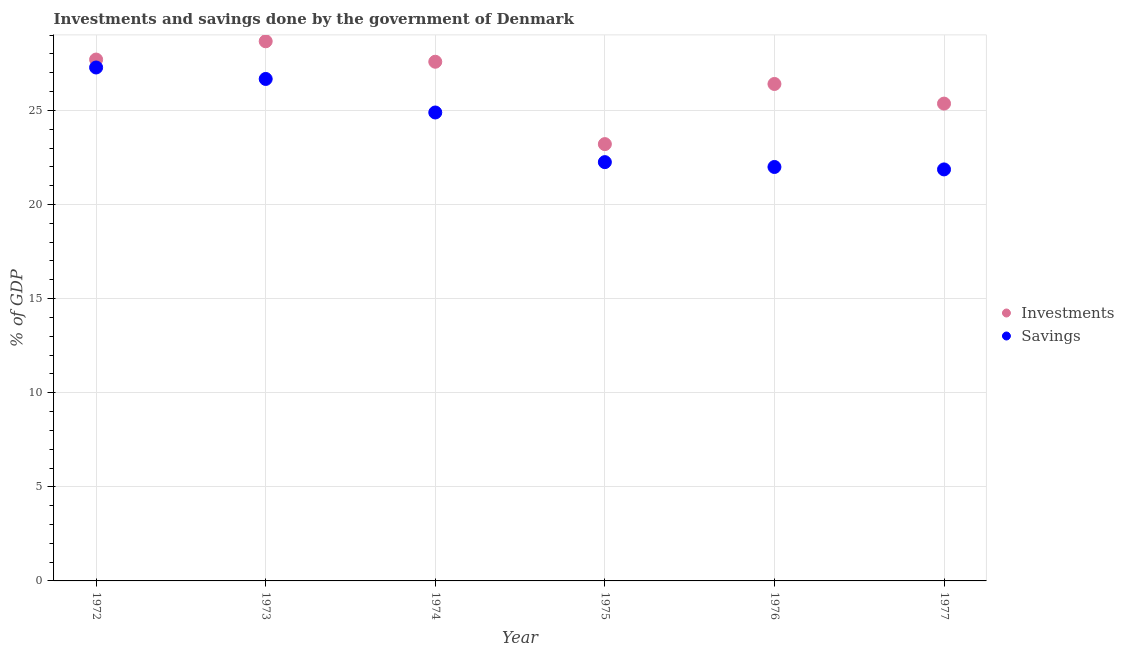How many different coloured dotlines are there?
Offer a terse response. 2. What is the investments of government in 1972?
Your answer should be very brief. 27.7. Across all years, what is the maximum investments of government?
Your answer should be very brief. 28.67. Across all years, what is the minimum savings of government?
Your answer should be compact. 21.87. In which year was the savings of government maximum?
Your response must be concise. 1972. In which year was the savings of government minimum?
Keep it short and to the point. 1977. What is the total savings of government in the graph?
Keep it short and to the point. 144.96. What is the difference between the savings of government in 1973 and that in 1976?
Make the answer very short. 4.68. What is the difference between the savings of government in 1975 and the investments of government in 1974?
Offer a very short reply. -5.33. What is the average savings of government per year?
Your answer should be compact. 24.16. In the year 1973, what is the difference between the investments of government and savings of government?
Ensure brevity in your answer.  2. In how many years, is the savings of government greater than 20 %?
Offer a terse response. 6. What is the ratio of the savings of government in 1972 to that in 1976?
Ensure brevity in your answer.  1.24. What is the difference between the highest and the second highest savings of government?
Offer a terse response. 0.61. What is the difference between the highest and the lowest savings of government?
Make the answer very short. 5.42. In how many years, is the investments of government greater than the average investments of government taken over all years?
Your answer should be compact. 3. Is the sum of the savings of government in 1974 and 1976 greater than the maximum investments of government across all years?
Provide a succinct answer. Yes. Is the investments of government strictly greater than the savings of government over the years?
Your answer should be very brief. Yes. Is the savings of government strictly less than the investments of government over the years?
Make the answer very short. Yes. How many dotlines are there?
Provide a short and direct response. 2. How many legend labels are there?
Provide a short and direct response. 2. What is the title of the graph?
Provide a short and direct response. Investments and savings done by the government of Denmark. What is the label or title of the X-axis?
Make the answer very short. Year. What is the label or title of the Y-axis?
Provide a succinct answer. % of GDP. What is the % of GDP in Investments in 1972?
Keep it short and to the point. 27.7. What is the % of GDP of Savings in 1972?
Your answer should be compact. 27.28. What is the % of GDP in Investments in 1973?
Your response must be concise. 28.67. What is the % of GDP in Savings in 1973?
Your answer should be compact. 26.67. What is the % of GDP of Investments in 1974?
Give a very brief answer. 27.59. What is the % of GDP in Savings in 1974?
Ensure brevity in your answer.  24.89. What is the % of GDP of Investments in 1975?
Offer a terse response. 23.21. What is the % of GDP in Savings in 1975?
Give a very brief answer. 22.25. What is the % of GDP in Investments in 1976?
Provide a succinct answer. 26.41. What is the % of GDP of Savings in 1976?
Give a very brief answer. 21.99. What is the % of GDP in Investments in 1977?
Offer a very short reply. 25.36. What is the % of GDP of Savings in 1977?
Provide a short and direct response. 21.87. Across all years, what is the maximum % of GDP in Investments?
Provide a short and direct response. 28.67. Across all years, what is the maximum % of GDP of Savings?
Your answer should be compact. 27.28. Across all years, what is the minimum % of GDP in Investments?
Give a very brief answer. 23.21. Across all years, what is the minimum % of GDP of Savings?
Keep it short and to the point. 21.87. What is the total % of GDP of Investments in the graph?
Ensure brevity in your answer.  158.94. What is the total % of GDP of Savings in the graph?
Offer a very short reply. 144.96. What is the difference between the % of GDP in Investments in 1972 and that in 1973?
Ensure brevity in your answer.  -0.97. What is the difference between the % of GDP in Savings in 1972 and that in 1973?
Your answer should be very brief. 0.61. What is the difference between the % of GDP in Investments in 1972 and that in 1974?
Your response must be concise. 0.12. What is the difference between the % of GDP of Savings in 1972 and that in 1974?
Make the answer very short. 2.39. What is the difference between the % of GDP in Investments in 1972 and that in 1975?
Your answer should be compact. 4.49. What is the difference between the % of GDP in Savings in 1972 and that in 1975?
Give a very brief answer. 5.03. What is the difference between the % of GDP in Investments in 1972 and that in 1976?
Give a very brief answer. 1.3. What is the difference between the % of GDP of Savings in 1972 and that in 1976?
Your response must be concise. 5.29. What is the difference between the % of GDP of Investments in 1972 and that in 1977?
Ensure brevity in your answer.  2.34. What is the difference between the % of GDP of Savings in 1972 and that in 1977?
Your response must be concise. 5.42. What is the difference between the % of GDP of Investments in 1973 and that in 1974?
Ensure brevity in your answer.  1.09. What is the difference between the % of GDP of Savings in 1973 and that in 1974?
Offer a very short reply. 1.78. What is the difference between the % of GDP in Investments in 1973 and that in 1975?
Your response must be concise. 5.46. What is the difference between the % of GDP in Savings in 1973 and that in 1975?
Offer a terse response. 4.42. What is the difference between the % of GDP in Investments in 1973 and that in 1976?
Provide a succinct answer. 2.27. What is the difference between the % of GDP in Savings in 1973 and that in 1976?
Offer a terse response. 4.68. What is the difference between the % of GDP of Investments in 1973 and that in 1977?
Ensure brevity in your answer.  3.31. What is the difference between the % of GDP in Savings in 1973 and that in 1977?
Keep it short and to the point. 4.81. What is the difference between the % of GDP in Investments in 1974 and that in 1975?
Your answer should be compact. 4.38. What is the difference between the % of GDP in Savings in 1974 and that in 1975?
Make the answer very short. 2.64. What is the difference between the % of GDP of Investments in 1974 and that in 1976?
Provide a succinct answer. 1.18. What is the difference between the % of GDP in Savings in 1974 and that in 1976?
Ensure brevity in your answer.  2.9. What is the difference between the % of GDP of Investments in 1974 and that in 1977?
Your answer should be very brief. 2.22. What is the difference between the % of GDP of Savings in 1974 and that in 1977?
Offer a very short reply. 3.02. What is the difference between the % of GDP of Investments in 1975 and that in 1976?
Ensure brevity in your answer.  -3.2. What is the difference between the % of GDP of Savings in 1975 and that in 1976?
Keep it short and to the point. 0.26. What is the difference between the % of GDP of Investments in 1975 and that in 1977?
Your response must be concise. -2.15. What is the difference between the % of GDP in Savings in 1975 and that in 1977?
Your response must be concise. 0.39. What is the difference between the % of GDP in Investments in 1976 and that in 1977?
Ensure brevity in your answer.  1.04. What is the difference between the % of GDP in Savings in 1976 and that in 1977?
Offer a terse response. 0.13. What is the difference between the % of GDP in Investments in 1972 and the % of GDP in Savings in 1973?
Give a very brief answer. 1.03. What is the difference between the % of GDP of Investments in 1972 and the % of GDP of Savings in 1974?
Ensure brevity in your answer.  2.81. What is the difference between the % of GDP in Investments in 1972 and the % of GDP in Savings in 1975?
Offer a very short reply. 5.45. What is the difference between the % of GDP of Investments in 1972 and the % of GDP of Savings in 1976?
Your answer should be very brief. 5.71. What is the difference between the % of GDP of Investments in 1972 and the % of GDP of Savings in 1977?
Offer a very short reply. 5.84. What is the difference between the % of GDP of Investments in 1973 and the % of GDP of Savings in 1974?
Provide a short and direct response. 3.78. What is the difference between the % of GDP in Investments in 1973 and the % of GDP in Savings in 1975?
Offer a terse response. 6.42. What is the difference between the % of GDP of Investments in 1973 and the % of GDP of Savings in 1976?
Offer a very short reply. 6.68. What is the difference between the % of GDP in Investments in 1973 and the % of GDP in Savings in 1977?
Give a very brief answer. 6.81. What is the difference between the % of GDP of Investments in 1974 and the % of GDP of Savings in 1975?
Give a very brief answer. 5.33. What is the difference between the % of GDP of Investments in 1974 and the % of GDP of Savings in 1976?
Provide a succinct answer. 5.59. What is the difference between the % of GDP in Investments in 1974 and the % of GDP in Savings in 1977?
Make the answer very short. 5.72. What is the difference between the % of GDP of Investments in 1975 and the % of GDP of Savings in 1976?
Give a very brief answer. 1.21. What is the difference between the % of GDP in Investments in 1975 and the % of GDP in Savings in 1977?
Your answer should be compact. 1.34. What is the difference between the % of GDP in Investments in 1976 and the % of GDP in Savings in 1977?
Offer a very short reply. 4.54. What is the average % of GDP in Investments per year?
Your answer should be very brief. 26.49. What is the average % of GDP of Savings per year?
Keep it short and to the point. 24.16. In the year 1972, what is the difference between the % of GDP in Investments and % of GDP in Savings?
Give a very brief answer. 0.42. In the year 1973, what is the difference between the % of GDP of Investments and % of GDP of Savings?
Provide a succinct answer. 2. In the year 1974, what is the difference between the % of GDP of Investments and % of GDP of Savings?
Offer a very short reply. 2.7. In the year 1975, what is the difference between the % of GDP of Investments and % of GDP of Savings?
Your response must be concise. 0.96. In the year 1976, what is the difference between the % of GDP of Investments and % of GDP of Savings?
Offer a terse response. 4.41. In the year 1977, what is the difference between the % of GDP in Investments and % of GDP in Savings?
Make the answer very short. 3.5. What is the ratio of the % of GDP in Investments in 1972 to that in 1973?
Your response must be concise. 0.97. What is the ratio of the % of GDP in Savings in 1972 to that in 1973?
Offer a terse response. 1.02. What is the ratio of the % of GDP in Investments in 1972 to that in 1974?
Offer a terse response. 1. What is the ratio of the % of GDP of Savings in 1972 to that in 1974?
Provide a short and direct response. 1.1. What is the ratio of the % of GDP of Investments in 1972 to that in 1975?
Your answer should be compact. 1.19. What is the ratio of the % of GDP of Savings in 1972 to that in 1975?
Make the answer very short. 1.23. What is the ratio of the % of GDP in Investments in 1972 to that in 1976?
Your answer should be compact. 1.05. What is the ratio of the % of GDP of Savings in 1972 to that in 1976?
Make the answer very short. 1.24. What is the ratio of the % of GDP of Investments in 1972 to that in 1977?
Offer a very short reply. 1.09. What is the ratio of the % of GDP in Savings in 1972 to that in 1977?
Your response must be concise. 1.25. What is the ratio of the % of GDP in Investments in 1973 to that in 1974?
Provide a short and direct response. 1.04. What is the ratio of the % of GDP in Savings in 1973 to that in 1974?
Make the answer very short. 1.07. What is the ratio of the % of GDP in Investments in 1973 to that in 1975?
Your answer should be compact. 1.24. What is the ratio of the % of GDP in Savings in 1973 to that in 1975?
Your answer should be compact. 1.2. What is the ratio of the % of GDP of Investments in 1973 to that in 1976?
Your response must be concise. 1.09. What is the ratio of the % of GDP in Savings in 1973 to that in 1976?
Offer a very short reply. 1.21. What is the ratio of the % of GDP of Investments in 1973 to that in 1977?
Your answer should be compact. 1.13. What is the ratio of the % of GDP of Savings in 1973 to that in 1977?
Your answer should be compact. 1.22. What is the ratio of the % of GDP in Investments in 1974 to that in 1975?
Make the answer very short. 1.19. What is the ratio of the % of GDP of Savings in 1974 to that in 1975?
Ensure brevity in your answer.  1.12. What is the ratio of the % of GDP in Investments in 1974 to that in 1976?
Give a very brief answer. 1.04. What is the ratio of the % of GDP of Savings in 1974 to that in 1976?
Give a very brief answer. 1.13. What is the ratio of the % of GDP of Investments in 1974 to that in 1977?
Make the answer very short. 1.09. What is the ratio of the % of GDP of Savings in 1974 to that in 1977?
Your response must be concise. 1.14. What is the ratio of the % of GDP of Investments in 1975 to that in 1976?
Offer a very short reply. 0.88. What is the ratio of the % of GDP of Savings in 1975 to that in 1976?
Provide a short and direct response. 1.01. What is the ratio of the % of GDP of Investments in 1975 to that in 1977?
Keep it short and to the point. 0.92. What is the ratio of the % of GDP in Savings in 1975 to that in 1977?
Your answer should be compact. 1.02. What is the ratio of the % of GDP of Investments in 1976 to that in 1977?
Your answer should be very brief. 1.04. What is the ratio of the % of GDP of Savings in 1976 to that in 1977?
Offer a terse response. 1.01. What is the difference between the highest and the second highest % of GDP in Investments?
Provide a short and direct response. 0.97. What is the difference between the highest and the second highest % of GDP of Savings?
Your response must be concise. 0.61. What is the difference between the highest and the lowest % of GDP in Investments?
Keep it short and to the point. 5.46. What is the difference between the highest and the lowest % of GDP in Savings?
Keep it short and to the point. 5.42. 